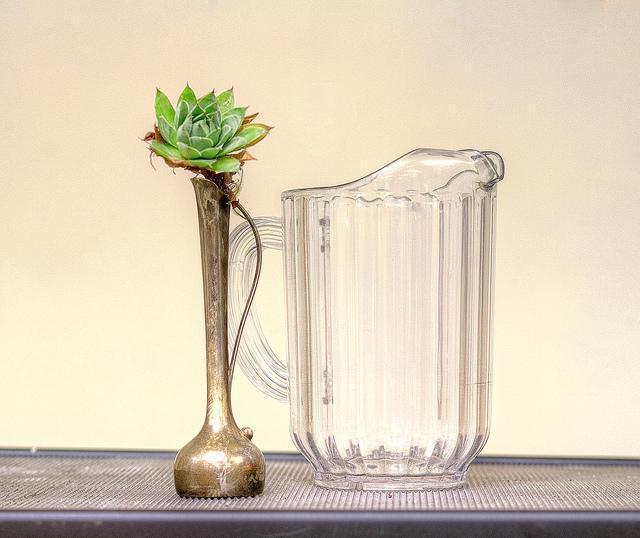What are they showing with this display?
Make your selection from the four choices given to correctly answer the question.
Options: Possibilities, randomness, contrast, colors. Contrast. 